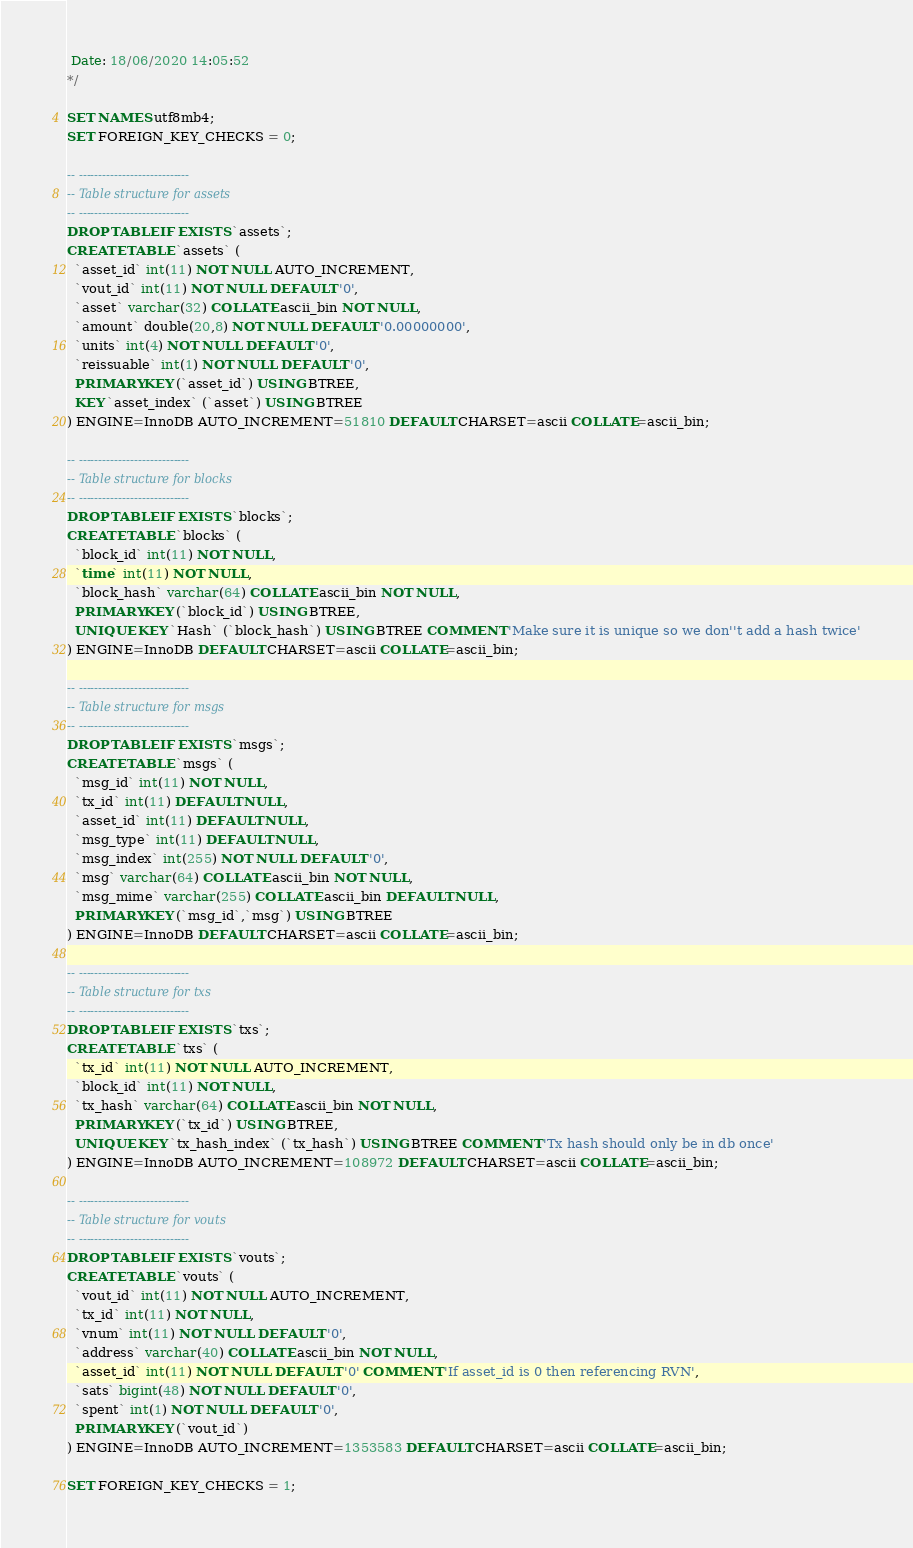Convert code to text. <code><loc_0><loc_0><loc_500><loc_500><_SQL_> Date: 18/06/2020 14:05:52
*/

SET NAMES utf8mb4;
SET FOREIGN_KEY_CHECKS = 0;

-- ----------------------------
-- Table structure for assets
-- ----------------------------
DROP TABLE IF EXISTS `assets`;
CREATE TABLE `assets` (
  `asset_id` int(11) NOT NULL AUTO_INCREMENT,
  `vout_id` int(11) NOT NULL DEFAULT '0',
  `asset` varchar(32) COLLATE ascii_bin NOT NULL,
  `amount` double(20,8) NOT NULL DEFAULT '0.00000000',
  `units` int(4) NOT NULL DEFAULT '0',
  `reissuable` int(1) NOT NULL DEFAULT '0',
  PRIMARY KEY (`asset_id`) USING BTREE,
  KEY `asset_index` (`asset`) USING BTREE
) ENGINE=InnoDB AUTO_INCREMENT=51810 DEFAULT CHARSET=ascii COLLATE=ascii_bin;

-- ----------------------------
-- Table structure for blocks
-- ----------------------------
DROP TABLE IF EXISTS `blocks`;
CREATE TABLE `blocks` (
  `block_id` int(11) NOT NULL,
  `time` int(11) NOT NULL,
  `block_hash` varchar(64) COLLATE ascii_bin NOT NULL,
  PRIMARY KEY (`block_id`) USING BTREE,
  UNIQUE KEY `Hash` (`block_hash`) USING BTREE COMMENT 'Make sure it is unique so we don''t add a hash twice'
) ENGINE=InnoDB DEFAULT CHARSET=ascii COLLATE=ascii_bin;

-- ----------------------------
-- Table structure for msgs
-- ----------------------------
DROP TABLE IF EXISTS `msgs`;
CREATE TABLE `msgs` (
  `msg_id` int(11) NOT NULL,
  `tx_id` int(11) DEFAULT NULL,
  `asset_id` int(11) DEFAULT NULL,
  `msg_type` int(11) DEFAULT NULL,
  `msg_index` int(255) NOT NULL DEFAULT '0',
  `msg` varchar(64) COLLATE ascii_bin NOT NULL,
  `msg_mime` varchar(255) COLLATE ascii_bin DEFAULT NULL,
  PRIMARY KEY (`msg_id`,`msg`) USING BTREE
) ENGINE=InnoDB DEFAULT CHARSET=ascii COLLATE=ascii_bin;

-- ----------------------------
-- Table structure for txs
-- ----------------------------
DROP TABLE IF EXISTS `txs`;
CREATE TABLE `txs` (
  `tx_id` int(11) NOT NULL AUTO_INCREMENT,
  `block_id` int(11) NOT NULL,
  `tx_hash` varchar(64) COLLATE ascii_bin NOT NULL,
  PRIMARY KEY (`tx_id`) USING BTREE,
  UNIQUE KEY `tx_hash_index` (`tx_hash`) USING BTREE COMMENT 'Tx hash should only be in db once'
) ENGINE=InnoDB AUTO_INCREMENT=108972 DEFAULT CHARSET=ascii COLLATE=ascii_bin;

-- ----------------------------
-- Table structure for vouts
-- ----------------------------
DROP TABLE IF EXISTS `vouts`;
CREATE TABLE `vouts` (
  `vout_id` int(11) NOT NULL AUTO_INCREMENT,
  `tx_id` int(11) NOT NULL,
  `vnum` int(11) NOT NULL DEFAULT '0',
  `address` varchar(40) COLLATE ascii_bin NOT NULL,
  `asset_id` int(11) NOT NULL DEFAULT '0' COMMENT 'If asset_id is 0 then referencing RVN',
  `sats` bigint(48) NOT NULL DEFAULT '0',
  `spent` int(1) NOT NULL DEFAULT '0',
  PRIMARY KEY (`vout_id`)
) ENGINE=InnoDB AUTO_INCREMENT=1353583 DEFAULT CHARSET=ascii COLLATE=ascii_bin;

SET FOREIGN_KEY_CHECKS = 1;
</code> 